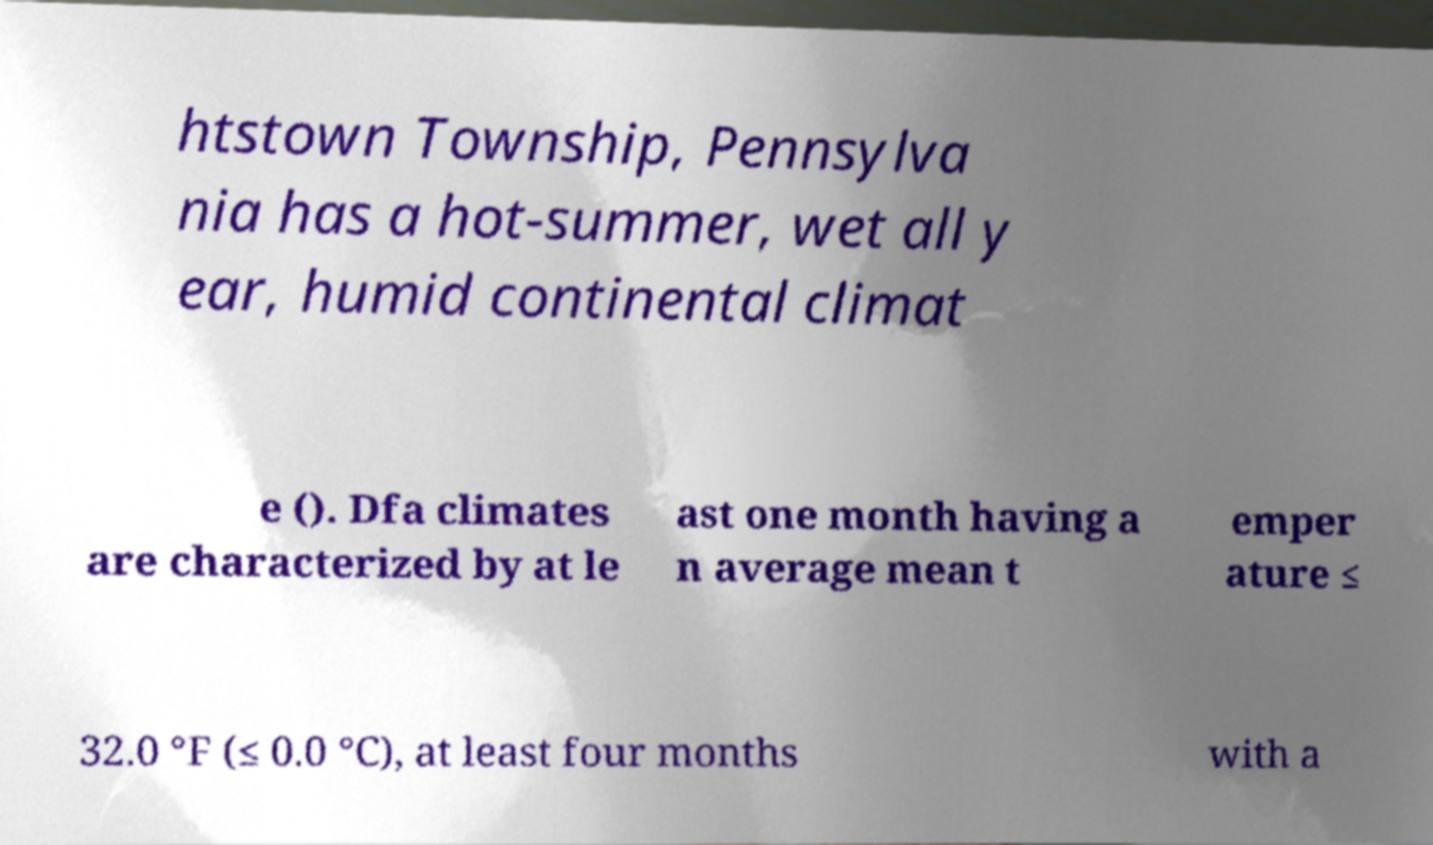There's text embedded in this image that I need extracted. Can you transcribe it verbatim? htstown Township, Pennsylva nia has a hot-summer, wet all y ear, humid continental climat e (). Dfa climates are characterized by at le ast one month having a n average mean t emper ature ≤ 32.0 °F (≤ 0.0 °C), at least four months with a 